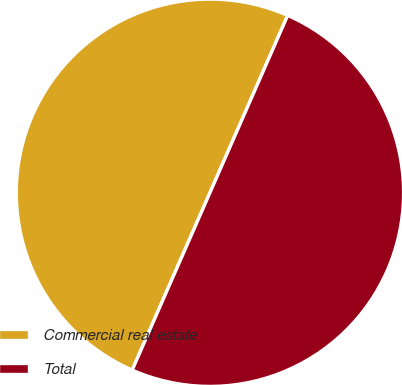Convert chart. <chart><loc_0><loc_0><loc_500><loc_500><pie_chart><fcel>Commercial real estate<fcel>Total<nl><fcel>50.0%<fcel>50.0%<nl></chart> 